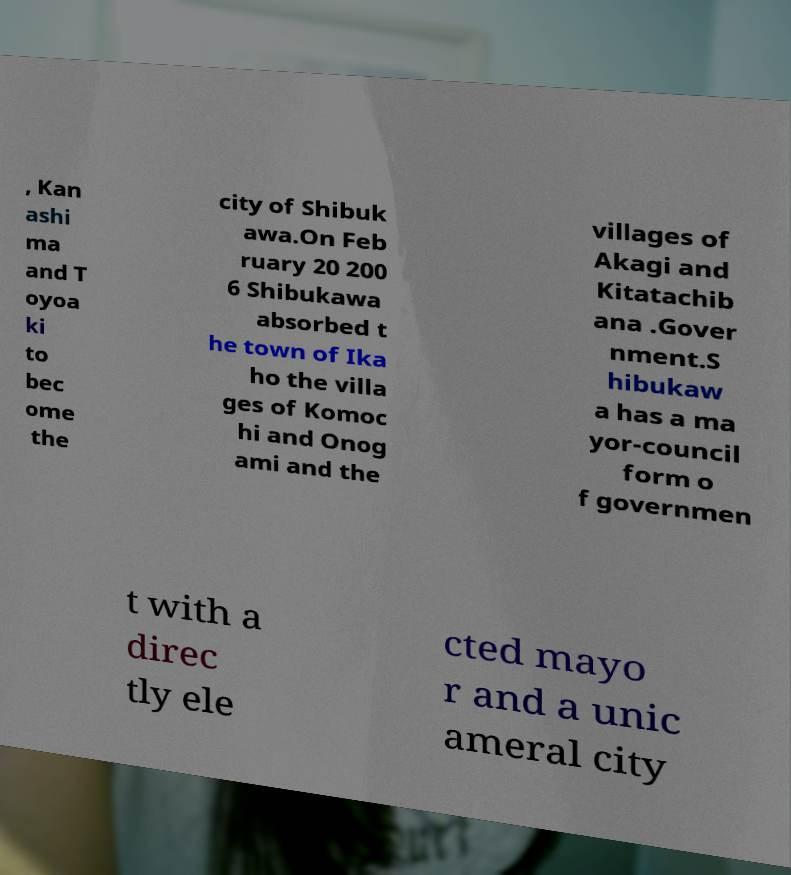There's text embedded in this image that I need extracted. Can you transcribe it verbatim? , Kan ashi ma and T oyoa ki to bec ome the city of Shibuk awa.On Feb ruary 20 200 6 Shibukawa absorbed t he town of Ika ho the villa ges of Komoc hi and Onog ami and the villages of Akagi and Kitatachib ana .Gover nment.S hibukaw a has a ma yor-council form o f governmen t with a direc tly ele cted mayo r and a unic ameral city 